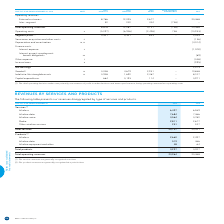According to Bce's financial document, How are the service revenues generally recognized? According to the financial document, over time. The relevant text states: "(1) Our service revenues are generally recognized over time...." Also, How are the product revenues generally recognized? According to the financial document, at a point in time. The relevant text states: "(2) Our product revenues are generally recognized at a point in time...." Also, What are the total operating revenues for 2019? According to the financial document, 23,964. The relevant text states: "Total operating revenues 23,964 23,468..." Also, How many categories are there under services? Counting the relevant items in the document: Wireless, Wireline data, Wireline voice, Media, Other wireline services, I find 5 instances. The key data points involved are: Media, Other wireline services, Wireless. Also, can you calculate: What is the average annual Total services? To answer this question, I need to perform calculations using the financial data. The calculation is: (20,737+20,441)/2, which equals 20589. This is based on the information: "Total services 20,737 20,441 Total services 20,737 20,441..." The key data points involved are: 20,441, 20,737. Additionally, Which segment when disaggregated has more types? According to the financial document, Services. The relevant text states: "Services (1)..." 